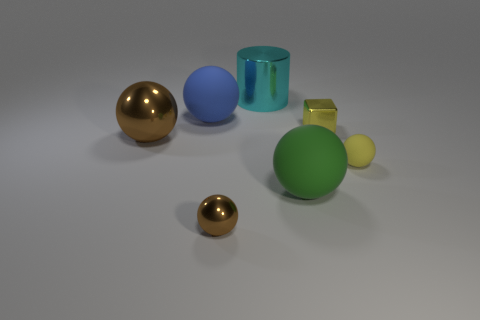Subtract all tiny yellow balls. How many balls are left? 4 Subtract all brown balls. How many balls are left? 3 Subtract 3 balls. How many balls are left? 2 Add 2 yellow rubber things. How many yellow rubber things exist? 3 Add 2 big green cylinders. How many objects exist? 9 Subtract 0 gray cylinders. How many objects are left? 7 Subtract all cylinders. How many objects are left? 6 Subtract all gray spheres. Subtract all yellow cylinders. How many spheres are left? 5 Subtract all blue cubes. How many brown spheres are left? 2 Subtract all yellow balls. Subtract all small yellow metallic objects. How many objects are left? 5 